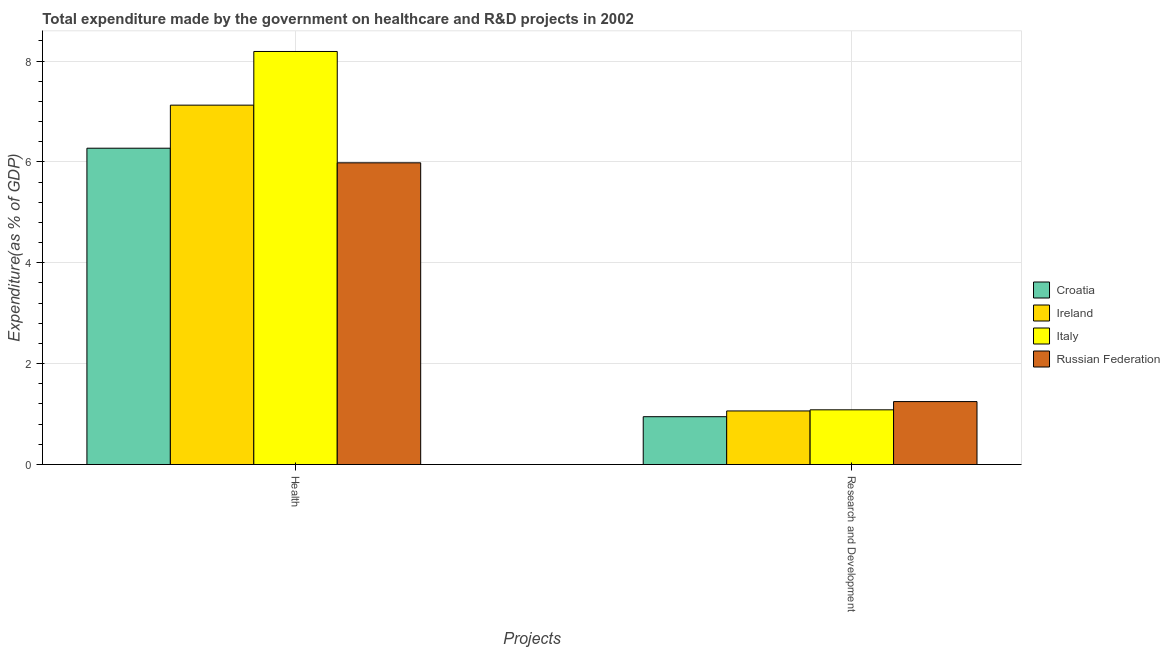How many different coloured bars are there?
Keep it short and to the point. 4. How many groups of bars are there?
Make the answer very short. 2. Are the number of bars per tick equal to the number of legend labels?
Give a very brief answer. Yes. Are the number of bars on each tick of the X-axis equal?
Your response must be concise. Yes. How many bars are there on the 2nd tick from the right?
Offer a very short reply. 4. What is the label of the 1st group of bars from the left?
Keep it short and to the point. Health. What is the expenditure in r&d in Croatia?
Keep it short and to the point. 0.95. Across all countries, what is the maximum expenditure in healthcare?
Make the answer very short. 8.19. Across all countries, what is the minimum expenditure in r&d?
Provide a succinct answer. 0.95. In which country was the expenditure in r&d maximum?
Provide a short and direct response. Russian Federation. In which country was the expenditure in r&d minimum?
Keep it short and to the point. Croatia. What is the total expenditure in r&d in the graph?
Offer a very short reply. 4.34. What is the difference between the expenditure in healthcare in Italy and that in Russian Federation?
Offer a very short reply. 2.21. What is the difference between the expenditure in healthcare in Croatia and the expenditure in r&d in Russian Federation?
Keep it short and to the point. 5.02. What is the average expenditure in healthcare per country?
Provide a succinct answer. 6.89. What is the difference between the expenditure in healthcare and expenditure in r&d in Ireland?
Ensure brevity in your answer.  6.06. In how many countries, is the expenditure in healthcare greater than 2.4 %?
Give a very brief answer. 4. What is the ratio of the expenditure in healthcare in Russian Federation to that in Croatia?
Offer a very short reply. 0.95. In how many countries, is the expenditure in healthcare greater than the average expenditure in healthcare taken over all countries?
Make the answer very short. 2. What does the 2nd bar from the left in Research and Development represents?
Make the answer very short. Ireland. What does the 3rd bar from the right in Research and Development represents?
Ensure brevity in your answer.  Ireland. Does the graph contain grids?
Provide a succinct answer. Yes. What is the title of the graph?
Make the answer very short. Total expenditure made by the government on healthcare and R&D projects in 2002. What is the label or title of the X-axis?
Your answer should be compact. Projects. What is the label or title of the Y-axis?
Your answer should be very brief. Expenditure(as % of GDP). What is the Expenditure(as % of GDP) of Croatia in Health?
Make the answer very short. 6.27. What is the Expenditure(as % of GDP) in Ireland in Health?
Your response must be concise. 7.13. What is the Expenditure(as % of GDP) in Italy in Health?
Your response must be concise. 8.19. What is the Expenditure(as % of GDP) of Russian Federation in Health?
Your answer should be very brief. 5.98. What is the Expenditure(as % of GDP) in Croatia in Research and Development?
Give a very brief answer. 0.95. What is the Expenditure(as % of GDP) in Ireland in Research and Development?
Offer a terse response. 1.06. What is the Expenditure(as % of GDP) of Italy in Research and Development?
Offer a very short reply. 1.08. What is the Expenditure(as % of GDP) in Russian Federation in Research and Development?
Give a very brief answer. 1.25. Across all Projects, what is the maximum Expenditure(as % of GDP) of Croatia?
Your response must be concise. 6.27. Across all Projects, what is the maximum Expenditure(as % of GDP) of Ireland?
Your answer should be very brief. 7.13. Across all Projects, what is the maximum Expenditure(as % of GDP) in Italy?
Your response must be concise. 8.19. Across all Projects, what is the maximum Expenditure(as % of GDP) in Russian Federation?
Keep it short and to the point. 5.98. Across all Projects, what is the minimum Expenditure(as % of GDP) of Croatia?
Make the answer very short. 0.95. Across all Projects, what is the minimum Expenditure(as % of GDP) of Ireland?
Provide a short and direct response. 1.06. Across all Projects, what is the minimum Expenditure(as % of GDP) of Italy?
Ensure brevity in your answer.  1.08. Across all Projects, what is the minimum Expenditure(as % of GDP) of Russian Federation?
Give a very brief answer. 1.25. What is the total Expenditure(as % of GDP) of Croatia in the graph?
Give a very brief answer. 7.22. What is the total Expenditure(as % of GDP) in Ireland in the graph?
Provide a succinct answer. 8.19. What is the total Expenditure(as % of GDP) of Italy in the graph?
Provide a succinct answer. 9.28. What is the total Expenditure(as % of GDP) in Russian Federation in the graph?
Ensure brevity in your answer.  7.23. What is the difference between the Expenditure(as % of GDP) of Croatia in Health and that in Research and Development?
Your response must be concise. 5.32. What is the difference between the Expenditure(as % of GDP) of Ireland in Health and that in Research and Development?
Your response must be concise. 6.06. What is the difference between the Expenditure(as % of GDP) of Italy in Health and that in Research and Development?
Offer a terse response. 7.11. What is the difference between the Expenditure(as % of GDP) of Russian Federation in Health and that in Research and Development?
Provide a short and direct response. 4.74. What is the difference between the Expenditure(as % of GDP) of Croatia in Health and the Expenditure(as % of GDP) of Ireland in Research and Development?
Keep it short and to the point. 5.21. What is the difference between the Expenditure(as % of GDP) of Croatia in Health and the Expenditure(as % of GDP) of Italy in Research and Development?
Offer a terse response. 5.19. What is the difference between the Expenditure(as % of GDP) of Croatia in Health and the Expenditure(as % of GDP) of Russian Federation in Research and Development?
Your response must be concise. 5.02. What is the difference between the Expenditure(as % of GDP) of Ireland in Health and the Expenditure(as % of GDP) of Italy in Research and Development?
Give a very brief answer. 6.04. What is the difference between the Expenditure(as % of GDP) in Ireland in Health and the Expenditure(as % of GDP) in Russian Federation in Research and Development?
Provide a short and direct response. 5.88. What is the difference between the Expenditure(as % of GDP) of Italy in Health and the Expenditure(as % of GDP) of Russian Federation in Research and Development?
Offer a very short reply. 6.94. What is the average Expenditure(as % of GDP) of Croatia per Projects?
Ensure brevity in your answer.  3.61. What is the average Expenditure(as % of GDP) in Ireland per Projects?
Offer a very short reply. 4.09. What is the average Expenditure(as % of GDP) in Italy per Projects?
Offer a very short reply. 4.64. What is the average Expenditure(as % of GDP) in Russian Federation per Projects?
Ensure brevity in your answer.  3.62. What is the difference between the Expenditure(as % of GDP) of Croatia and Expenditure(as % of GDP) of Ireland in Health?
Your answer should be compact. -0.85. What is the difference between the Expenditure(as % of GDP) of Croatia and Expenditure(as % of GDP) of Italy in Health?
Your answer should be compact. -1.92. What is the difference between the Expenditure(as % of GDP) of Croatia and Expenditure(as % of GDP) of Russian Federation in Health?
Offer a terse response. 0.29. What is the difference between the Expenditure(as % of GDP) of Ireland and Expenditure(as % of GDP) of Italy in Health?
Offer a terse response. -1.06. What is the difference between the Expenditure(as % of GDP) in Ireland and Expenditure(as % of GDP) in Russian Federation in Health?
Your answer should be very brief. 1.14. What is the difference between the Expenditure(as % of GDP) in Italy and Expenditure(as % of GDP) in Russian Federation in Health?
Offer a terse response. 2.21. What is the difference between the Expenditure(as % of GDP) in Croatia and Expenditure(as % of GDP) in Ireland in Research and Development?
Make the answer very short. -0.11. What is the difference between the Expenditure(as % of GDP) of Croatia and Expenditure(as % of GDP) of Italy in Research and Development?
Offer a terse response. -0.14. What is the difference between the Expenditure(as % of GDP) of Croatia and Expenditure(as % of GDP) of Russian Federation in Research and Development?
Your answer should be compact. -0.3. What is the difference between the Expenditure(as % of GDP) in Ireland and Expenditure(as % of GDP) in Italy in Research and Development?
Give a very brief answer. -0.02. What is the difference between the Expenditure(as % of GDP) in Ireland and Expenditure(as % of GDP) in Russian Federation in Research and Development?
Keep it short and to the point. -0.19. What is the difference between the Expenditure(as % of GDP) of Italy and Expenditure(as % of GDP) of Russian Federation in Research and Development?
Provide a succinct answer. -0.16. What is the ratio of the Expenditure(as % of GDP) in Croatia in Health to that in Research and Development?
Offer a terse response. 6.62. What is the ratio of the Expenditure(as % of GDP) in Ireland in Health to that in Research and Development?
Your answer should be compact. 6.71. What is the ratio of the Expenditure(as % of GDP) in Italy in Health to that in Research and Development?
Make the answer very short. 7.55. What is the ratio of the Expenditure(as % of GDP) of Russian Federation in Health to that in Research and Development?
Your answer should be compact. 4.79. What is the difference between the highest and the second highest Expenditure(as % of GDP) in Croatia?
Give a very brief answer. 5.32. What is the difference between the highest and the second highest Expenditure(as % of GDP) of Ireland?
Provide a short and direct response. 6.06. What is the difference between the highest and the second highest Expenditure(as % of GDP) of Italy?
Your answer should be compact. 7.11. What is the difference between the highest and the second highest Expenditure(as % of GDP) in Russian Federation?
Your answer should be compact. 4.74. What is the difference between the highest and the lowest Expenditure(as % of GDP) of Croatia?
Provide a succinct answer. 5.32. What is the difference between the highest and the lowest Expenditure(as % of GDP) in Ireland?
Offer a terse response. 6.06. What is the difference between the highest and the lowest Expenditure(as % of GDP) of Italy?
Ensure brevity in your answer.  7.11. What is the difference between the highest and the lowest Expenditure(as % of GDP) of Russian Federation?
Ensure brevity in your answer.  4.74. 